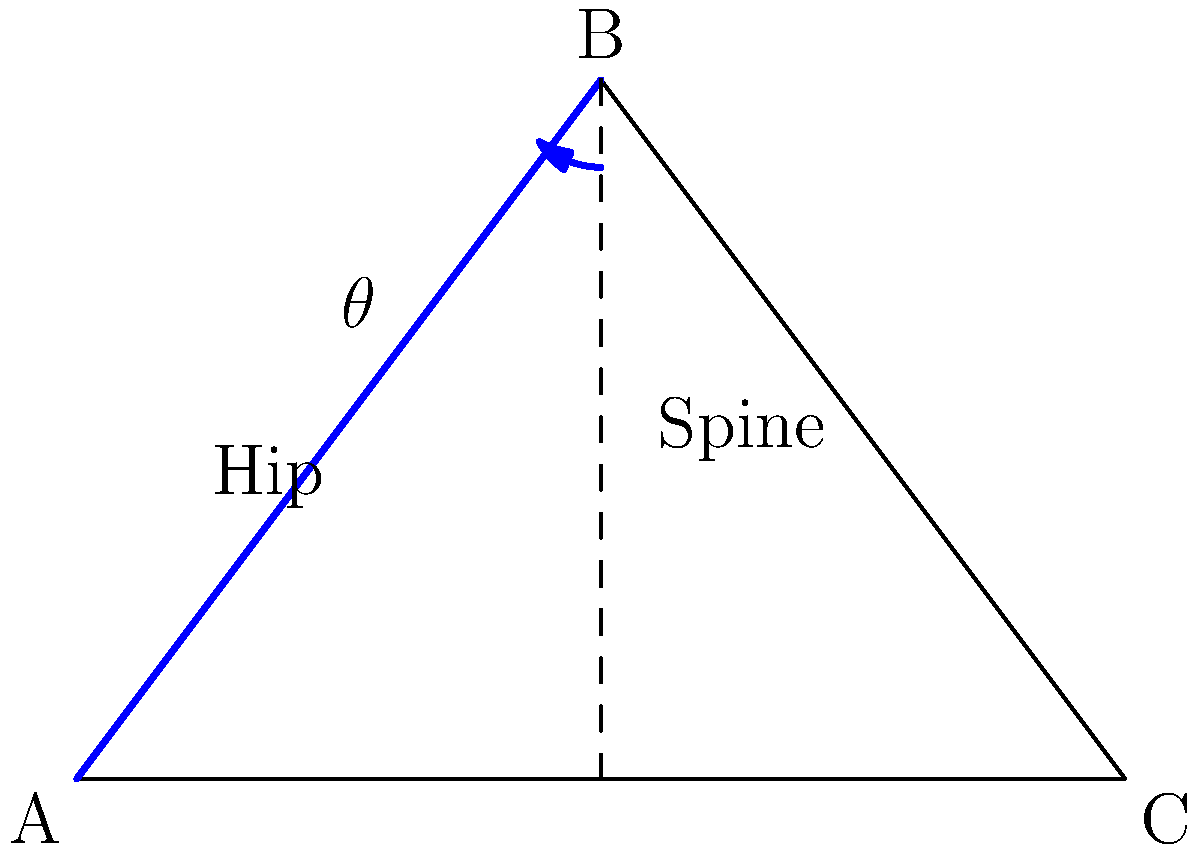In a photoshoot, you're asked to strike a pose that creates a triangular shape with your body. The photographer wants you to adjust your hip angle ($\theta$) to optimize the aesthetic appeal of the pose. If the triangle formed by your body has sides of length 5, 4, and 3 units, what should be the approximate hip angle ($\theta$) to create the most visually balanced pose? To find the optimal hip angle for the most visually balanced pose, we can use the principle of the "golden ratio" in photography, which is approximately 1.618. This ratio is often considered aesthetically pleasing in art and photography.

Let's approach this step-by-step:

1) First, we need to identify which angle in the triangle corresponds to the hip angle. In this case, it's the angle opposite the side with length 4 units.

2) We can use the cosine law to find this angle:

   $$\cos \theta = \frac{a^2 + b^2 - c^2}{2ab}$$

   where $a$ and $b$ are the sides adjacent to the angle, and $c$ is the side opposite to it.

3) Plugging in our values:

   $$\cos \theta = \frac{5^2 + 3^2 - 4^2}{2(5)(3)} = \frac{25 + 9 - 16}{30} = \frac{18}{30} = 0.6$$

4) Taking the inverse cosine (arccos) of both sides:

   $$\theta = \arccos(0.6) \approx 53.13°$$

5) Now, to check if this angle creates a visually balanced pose, we can compare the ratio of the larger part of the triangle to the smaller part. In a golden triangle, this ratio should be close to 1.618.

6) The height of the triangle can be calculated using the sine of the angle:

   $$h = 3 \sin(53.13°) \approx 2.4$$

7) This divides the base (5 units) into two parts. Let's call the smaller part $x$. We can find $x$ using the Pythagorean theorem:

   $$x^2 + 2.4^2 = 3^2$$
   $$x \approx 1.8$$

8) The larger part of the base is therefore $5 - 1.8 = 3.2$

9) The ratio of the larger part to the smaller part is:

   $$\frac{3.2}{1.8} \approx 1.78$$

This ratio is reasonably close to the golden ratio of 1.618, suggesting that this hip angle creates a visually balanced and aesthetically pleasing pose.
Answer: Approximately 53° 